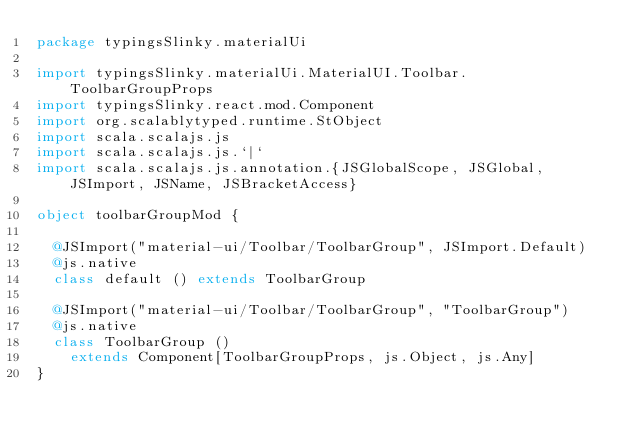<code> <loc_0><loc_0><loc_500><loc_500><_Scala_>package typingsSlinky.materialUi

import typingsSlinky.materialUi.MaterialUI.Toolbar.ToolbarGroupProps
import typingsSlinky.react.mod.Component
import org.scalablytyped.runtime.StObject
import scala.scalajs.js
import scala.scalajs.js.`|`
import scala.scalajs.js.annotation.{JSGlobalScope, JSGlobal, JSImport, JSName, JSBracketAccess}

object toolbarGroupMod {
  
  @JSImport("material-ui/Toolbar/ToolbarGroup", JSImport.Default)
  @js.native
  class default () extends ToolbarGroup
  
  @JSImport("material-ui/Toolbar/ToolbarGroup", "ToolbarGroup")
  @js.native
  class ToolbarGroup ()
    extends Component[ToolbarGroupProps, js.Object, js.Any]
}
</code> 